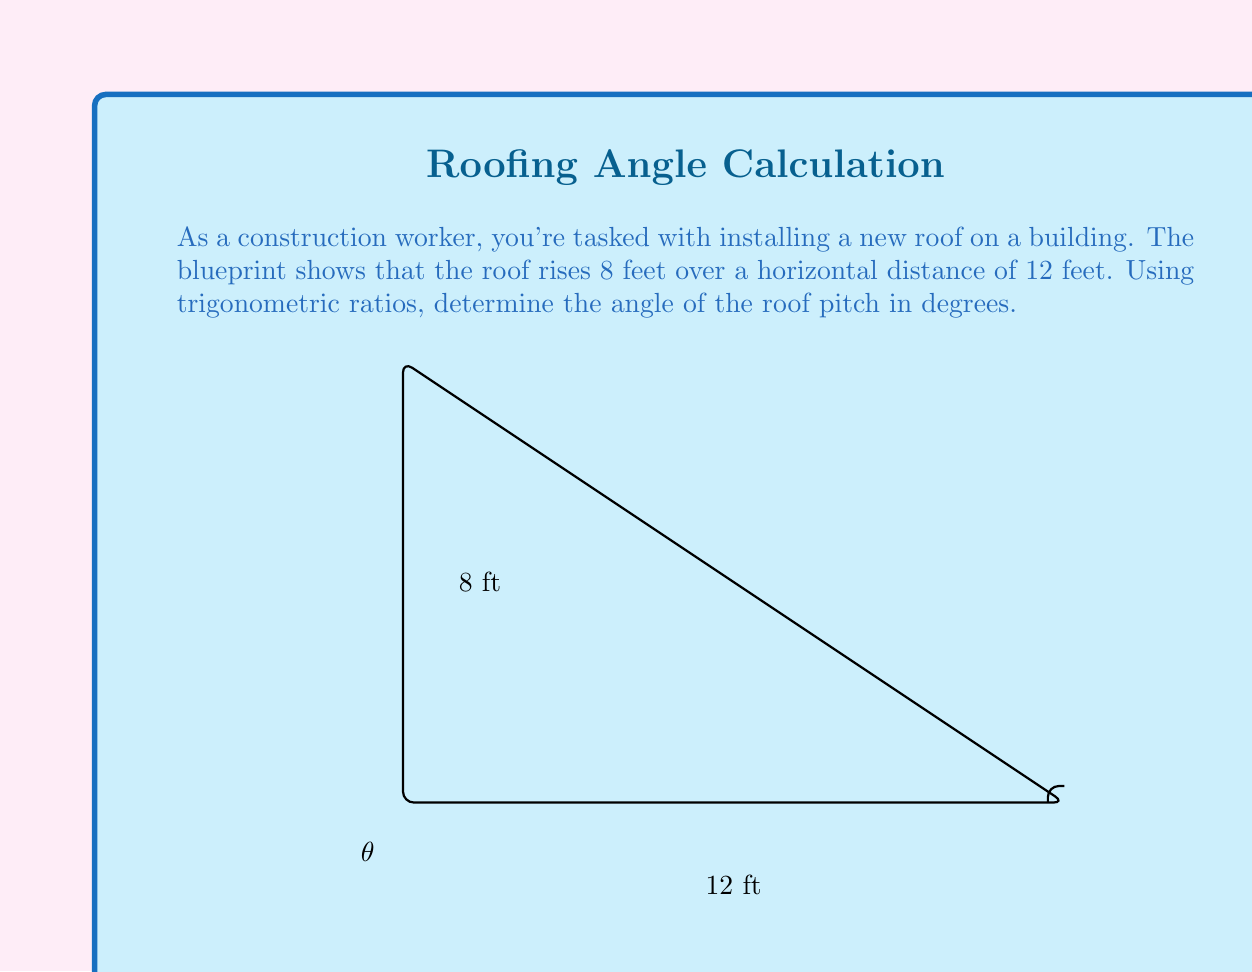Help me with this question. To solve this problem, we'll use the tangent ratio in a right triangle. The tangent of an angle is the ratio of the opposite side to the adjacent side.

1) In this case, we have:
   - Opposite side (rise) = 8 feet
   - Adjacent side (run) = 12 feet

2) The tangent of the angle $\theta$ is:

   $$\tan(\theta) = \frac{\text{opposite}}{\text{adjacent}} = \frac{8}{12} = \frac{2}{3}$$

3) To find the angle, we need to use the inverse tangent (arctan or $\tan^{-1}$) function:

   $$\theta = \tan^{-1}(\frac{2}{3})$$

4) Using a calculator or trigonometric tables:

   $$\theta \approx 33.69^\circ$$

5) In construction, it's common to round to the nearest degree, so we'll round to 34°.

The roof pitch can also be expressed as a ratio of rise over run, which in this case is 8:12 or 2:3.
Answer: The angle of the roof pitch is approximately 34°. 